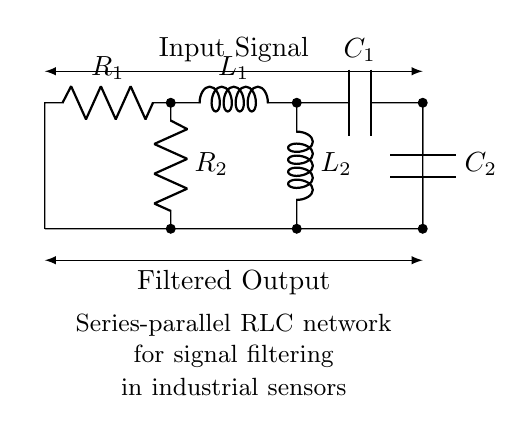What components are present in this circuit? The circuit includes two resistors (R1 and R2), two inductors (L1 and L2), and two capacitors (C1 and C2). They are explicitly labeled in the diagram, allowing for an easy identification of the components.
Answer: resistors, inductors, capacitors What is the configuration of R2, L2, and C2 in the circuit? R2, L2, and C2 are connected in parallel to the series path formed by R1, L1, and C1. This can be determined by their direct connections to the common nodes at the bottom of the circuit, which implies parallel arrangement.
Answer: parallel How many energy storage elements are in the circuit? There are four energy storage elements: two inductors and two capacitors. Inductors store energy in a magnetic field, while capacitors store energy in an electric field. The circuit features both types, making a total of four.
Answer: four What effect does this RLC network have on signals? This RLC network is designed to filter signals, primarily by attenuating unwanted frequencies while passing desired frequencies through. The combination of resistors, inductors, and capacitors provides specific frequency response characteristics which are typical in filtering applications.
Answer: filtering What would be the primary function of this circuit in industrial sensors? The primary function is signal conditioning, which involves filtering noise or unwanted signals to enhance the quality of the output signal from industrial sensors. This is critical in ensuring accurate readings and reliable operation.
Answer: signal conditioning What type of filter configuration does this circuit represent? This circuit represents a second-order filter because it consists of two reactive (inductor and capacitor) components coupled with a resistor, impacting the filtering behavior more severely than a first-order configuration.
Answer: second-order filter 